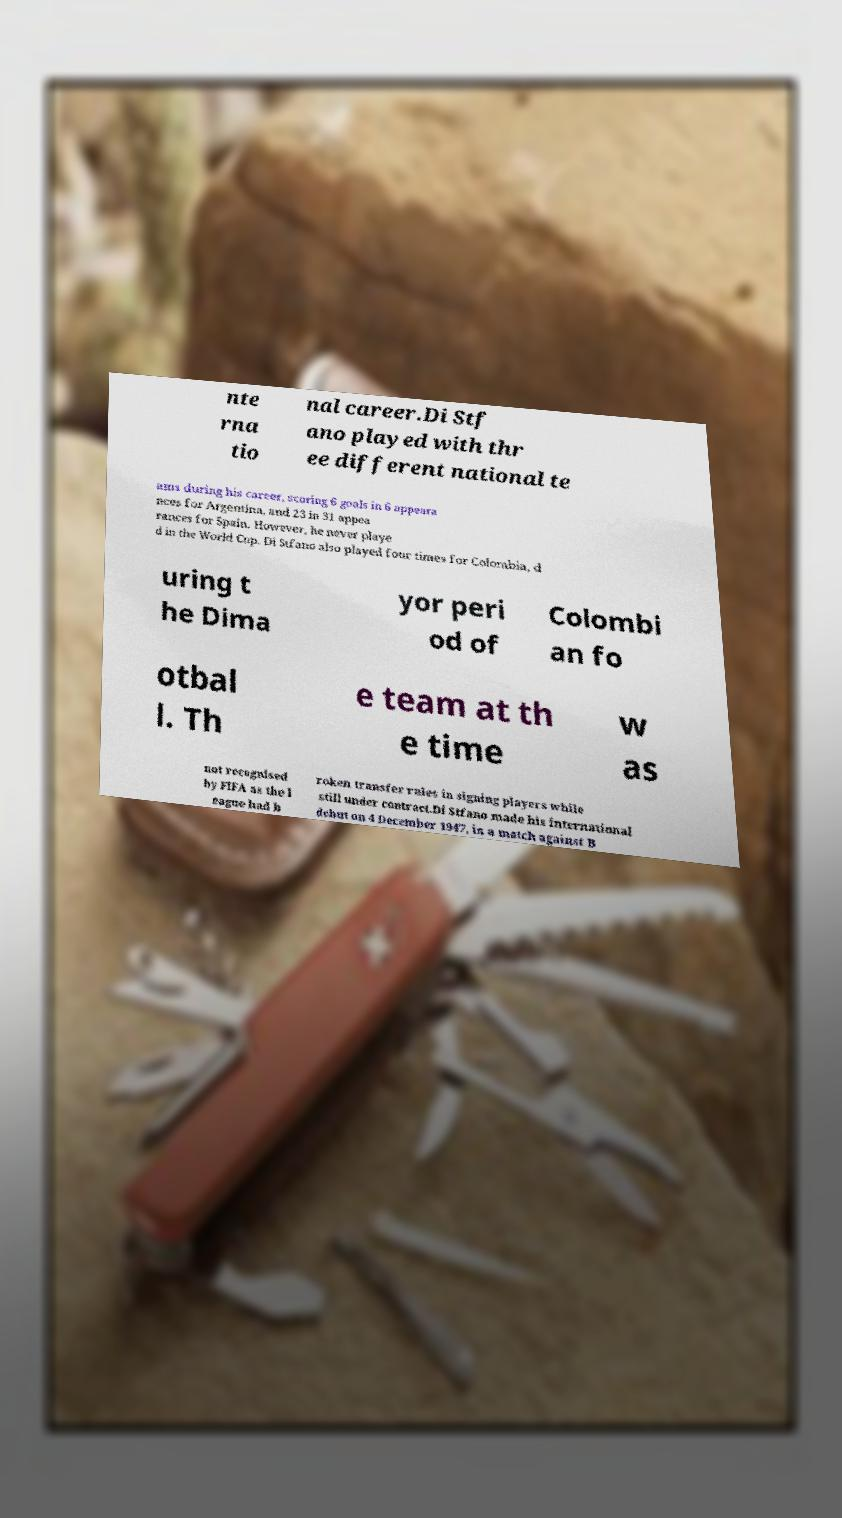There's text embedded in this image that I need extracted. Can you transcribe it verbatim? nte rna tio nal career.Di Stf ano played with thr ee different national te ams during his career, scoring 6 goals in 6 appeara nces for Argentina, and 23 in 31 appea rances for Spain. However, he never playe d in the World Cup. Di Stfano also played four times for Colombia, d uring t he Dima yor peri od of Colombi an fo otbal l. Th e team at th e time w as not recognised by FIFA as the l eague had b roken transfer rules in signing players while still under contract.Di Stfano made his international debut on 4 December 1947, in a match against B 